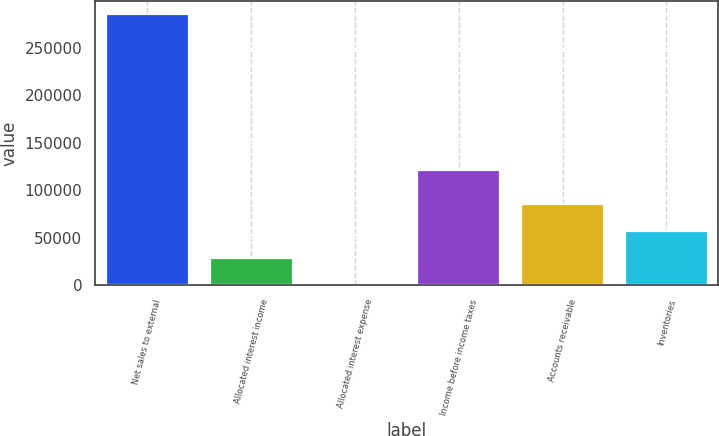Convert chart. <chart><loc_0><loc_0><loc_500><loc_500><bar_chart><fcel>Net sales to external<fcel>Allocated interest income<fcel>Allocated interest expense<fcel>Income before income taxes<fcel>Accounts receivable<fcel>Inventories<nl><fcel>285362<fcel>28575.8<fcel>44<fcel>120905<fcel>85639.4<fcel>57107.6<nl></chart> 